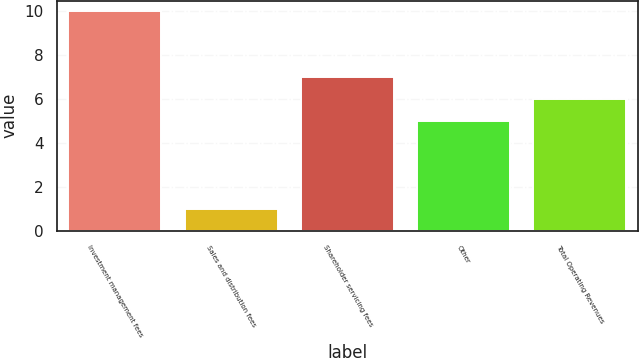Convert chart. <chart><loc_0><loc_0><loc_500><loc_500><bar_chart><fcel>Investment management fees<fcel>Sales and distribution fees<fcel>Shareholder servicing fees<fcel>Other<fcel>Total Operating Revenues<nl><fcel>10<fcel>1<fcel>7<fcel>5<fcel>6<nl></chart> 